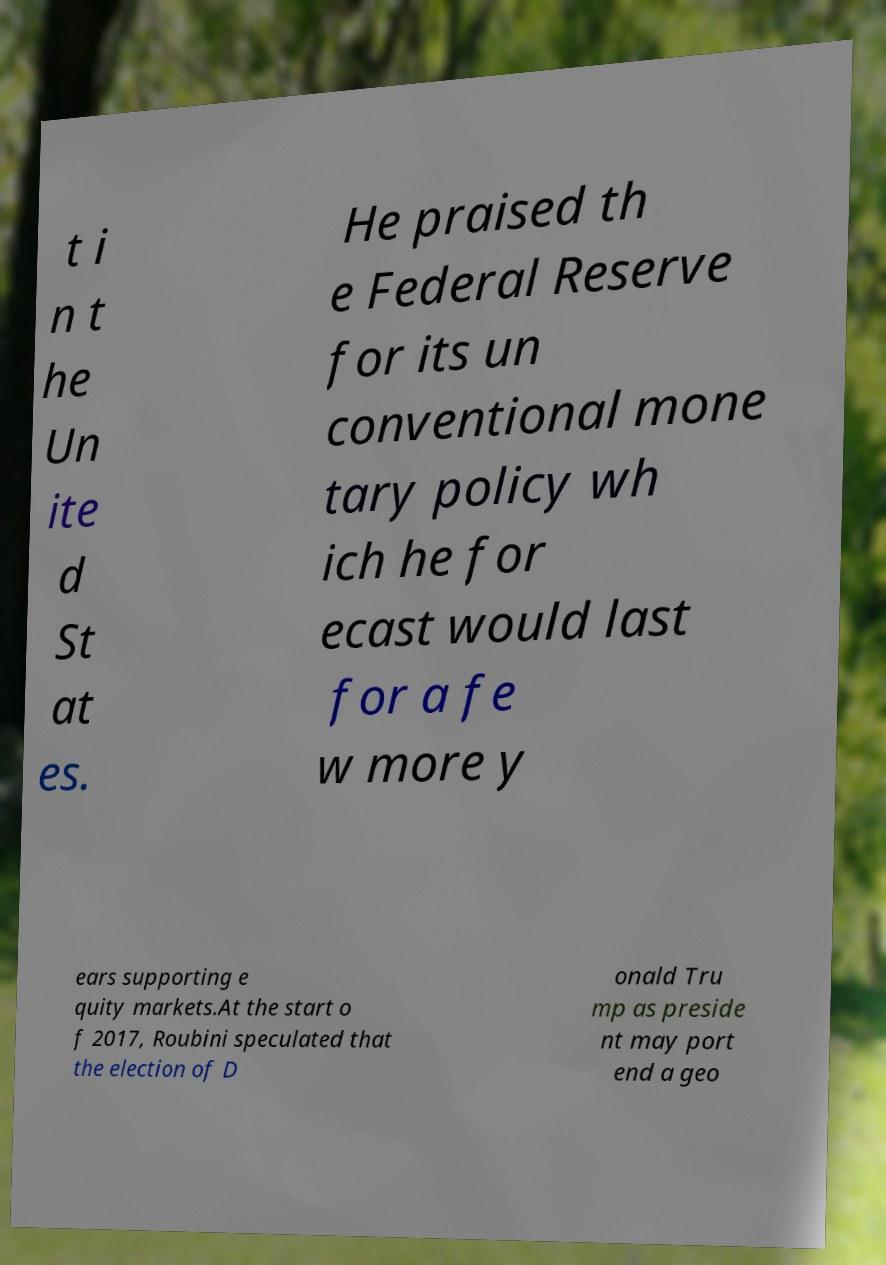Could you assist in decoding the text presented in this image and type it out clearly? t i n t he Un ite d St at es. He praised th e Federal Reserve for its un conventional mone tary policy wh ich he for ecast would last for a fe w more y ears supporting e quity markets.At the start o f 2017, Roubini speculated that the election of D onald Tru mp as preside nt may port end a geo 